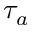<formula> <loc_0><loc_0><loc_500><loc_500>\tau _ { a }</formula> 